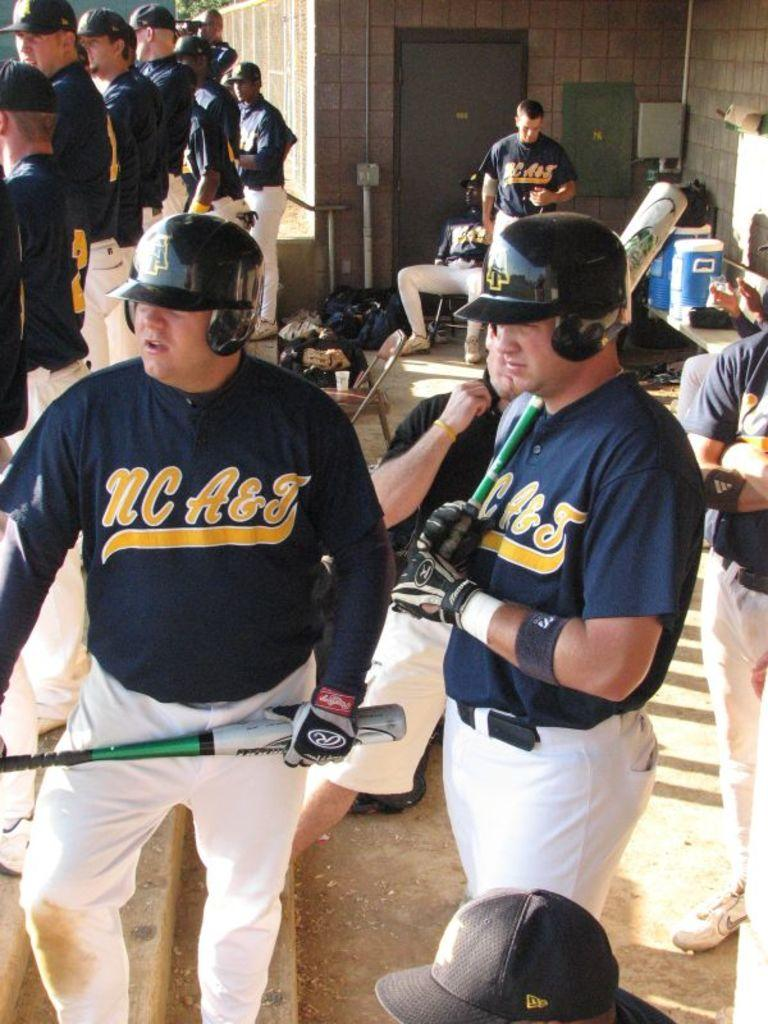<image>
Present a compact description of the photo's key features. Two men wearing blue tops with NC A&J wait to go out and bat. 